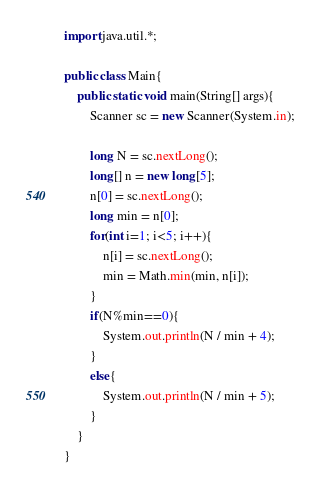Convert code to text. <code><loc_0><loc_0><loc_500><loc_500><_Java_>import java.util.*;
 
public class Main{
    public static void main(String[] args){
        Scanner sc = new Scanner(System.in);
 
        long N = sc.nextLong();
        long[] n = new long[5];
        n[0] = sc.nextLong();
        long min = n[0];
        for(int i=1; i<5; i++){
            n[i] = sc.nextLong();
            min = Math.min(min, n[i]);
        }
        if(N%min==0){
            System.out.println(N / min + 4);
        }
        else{
            System.out.println(N / min + 5);
        }
    }
}</code> 